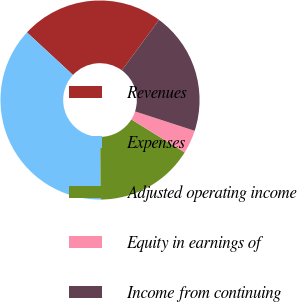Convert chart. <chart><loc_0><loc_0><loc_500><loc_500><pie_chart><fcel>Revenues<fcel>Expenses<fcel>Adjusted operating income<fcel>Equity in earnings of<fcel>Income from continuing<nl><fcel>23.22%<fcel>36.98%<fcel>16.09%<fcel>3.81%<fcel>19.9%<nl></chart> 